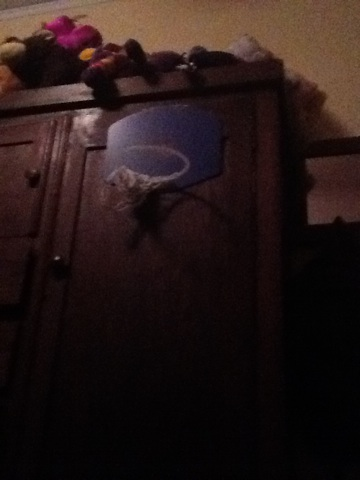Can you describe what you see in this image? In the image, I see a small basketball hoop mounted on a piece of furniture, which looks like a wooden wardrobe or cabinet. There are several stuffed animals placed on top of the furniture, adding a playful and cozy atmosphere to the room. What else can you infer about the room from this image? From the image, it appears that this room might belong to a child or a young person who enjoys playing basketball indoors. The presence of stuffed animals suggests a playful and youthful environment, and the furniture looks like it could be part of a bedroom or a playroom. 